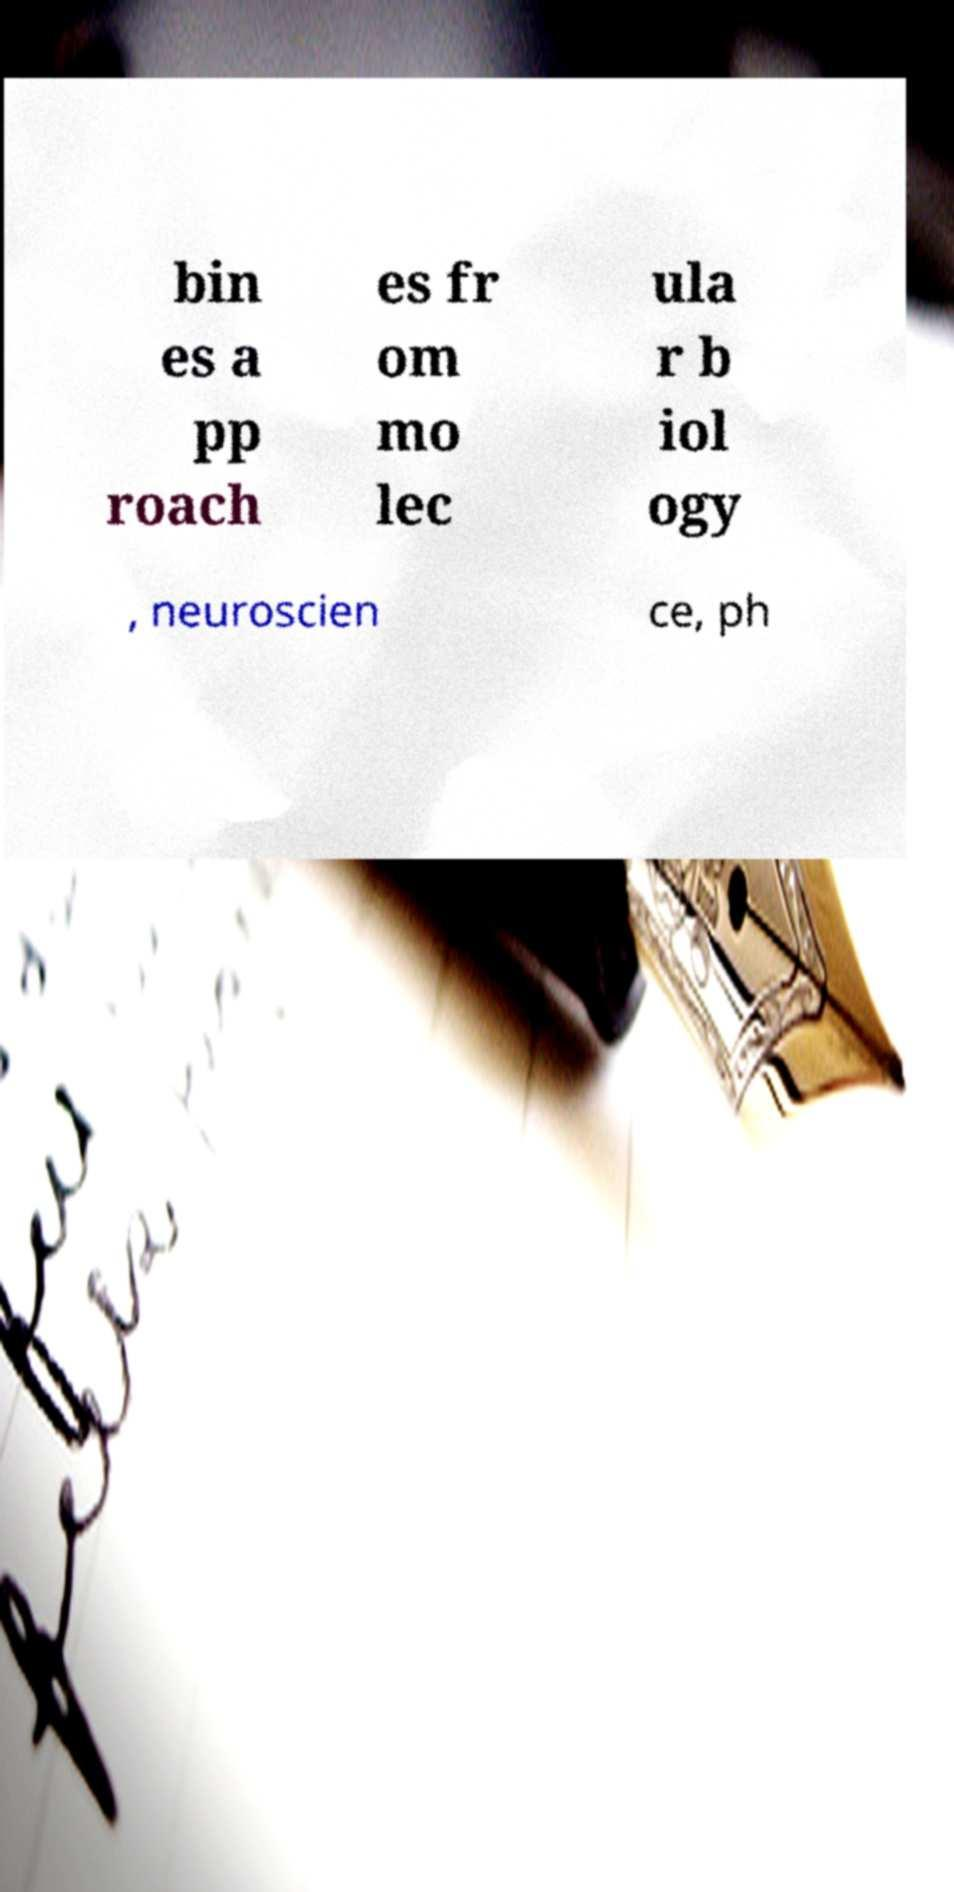I need the written content from this picture converted into text. Can you do that? bin es a pp roach es fr om mo lec ula r b iol ogy , neuroscien ce, ph 